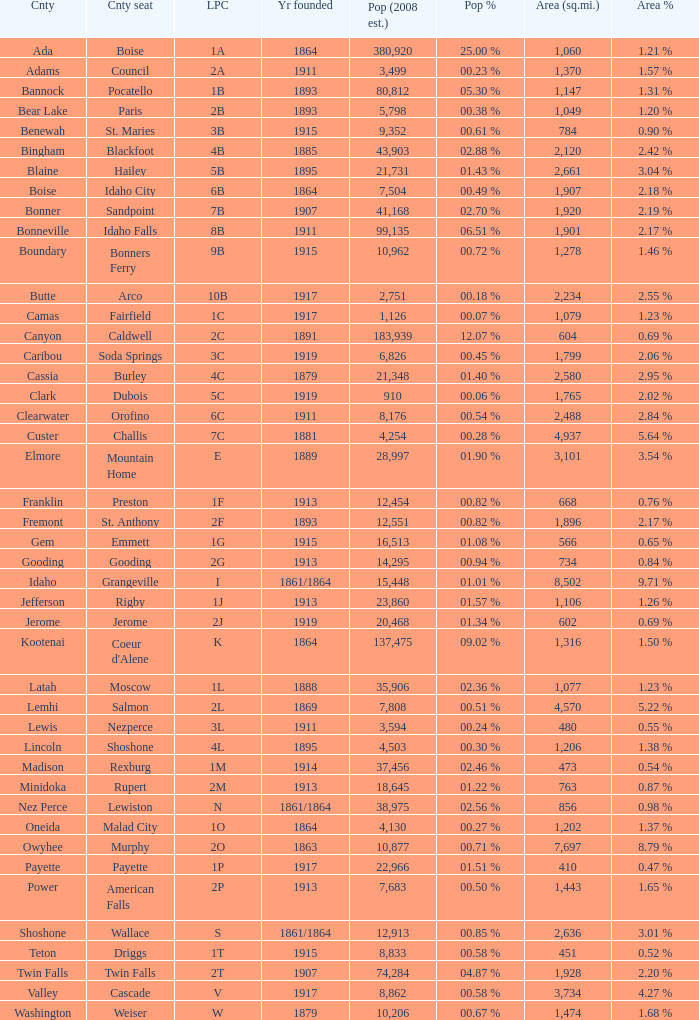What is the license plate code for the country with an area of 784? 3B. 